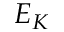Convert formula to latex. <formula><loc_0><loc_0><loc_500><loc_500>E _ { K }</formula> 